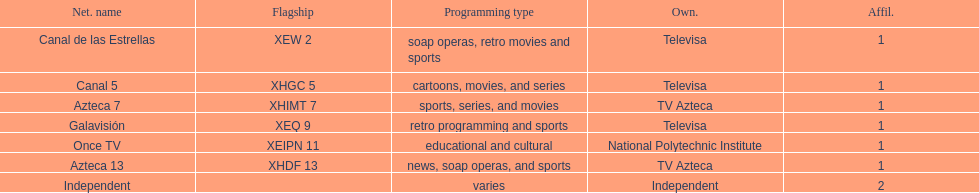How many networks does televisa possess? 3. 